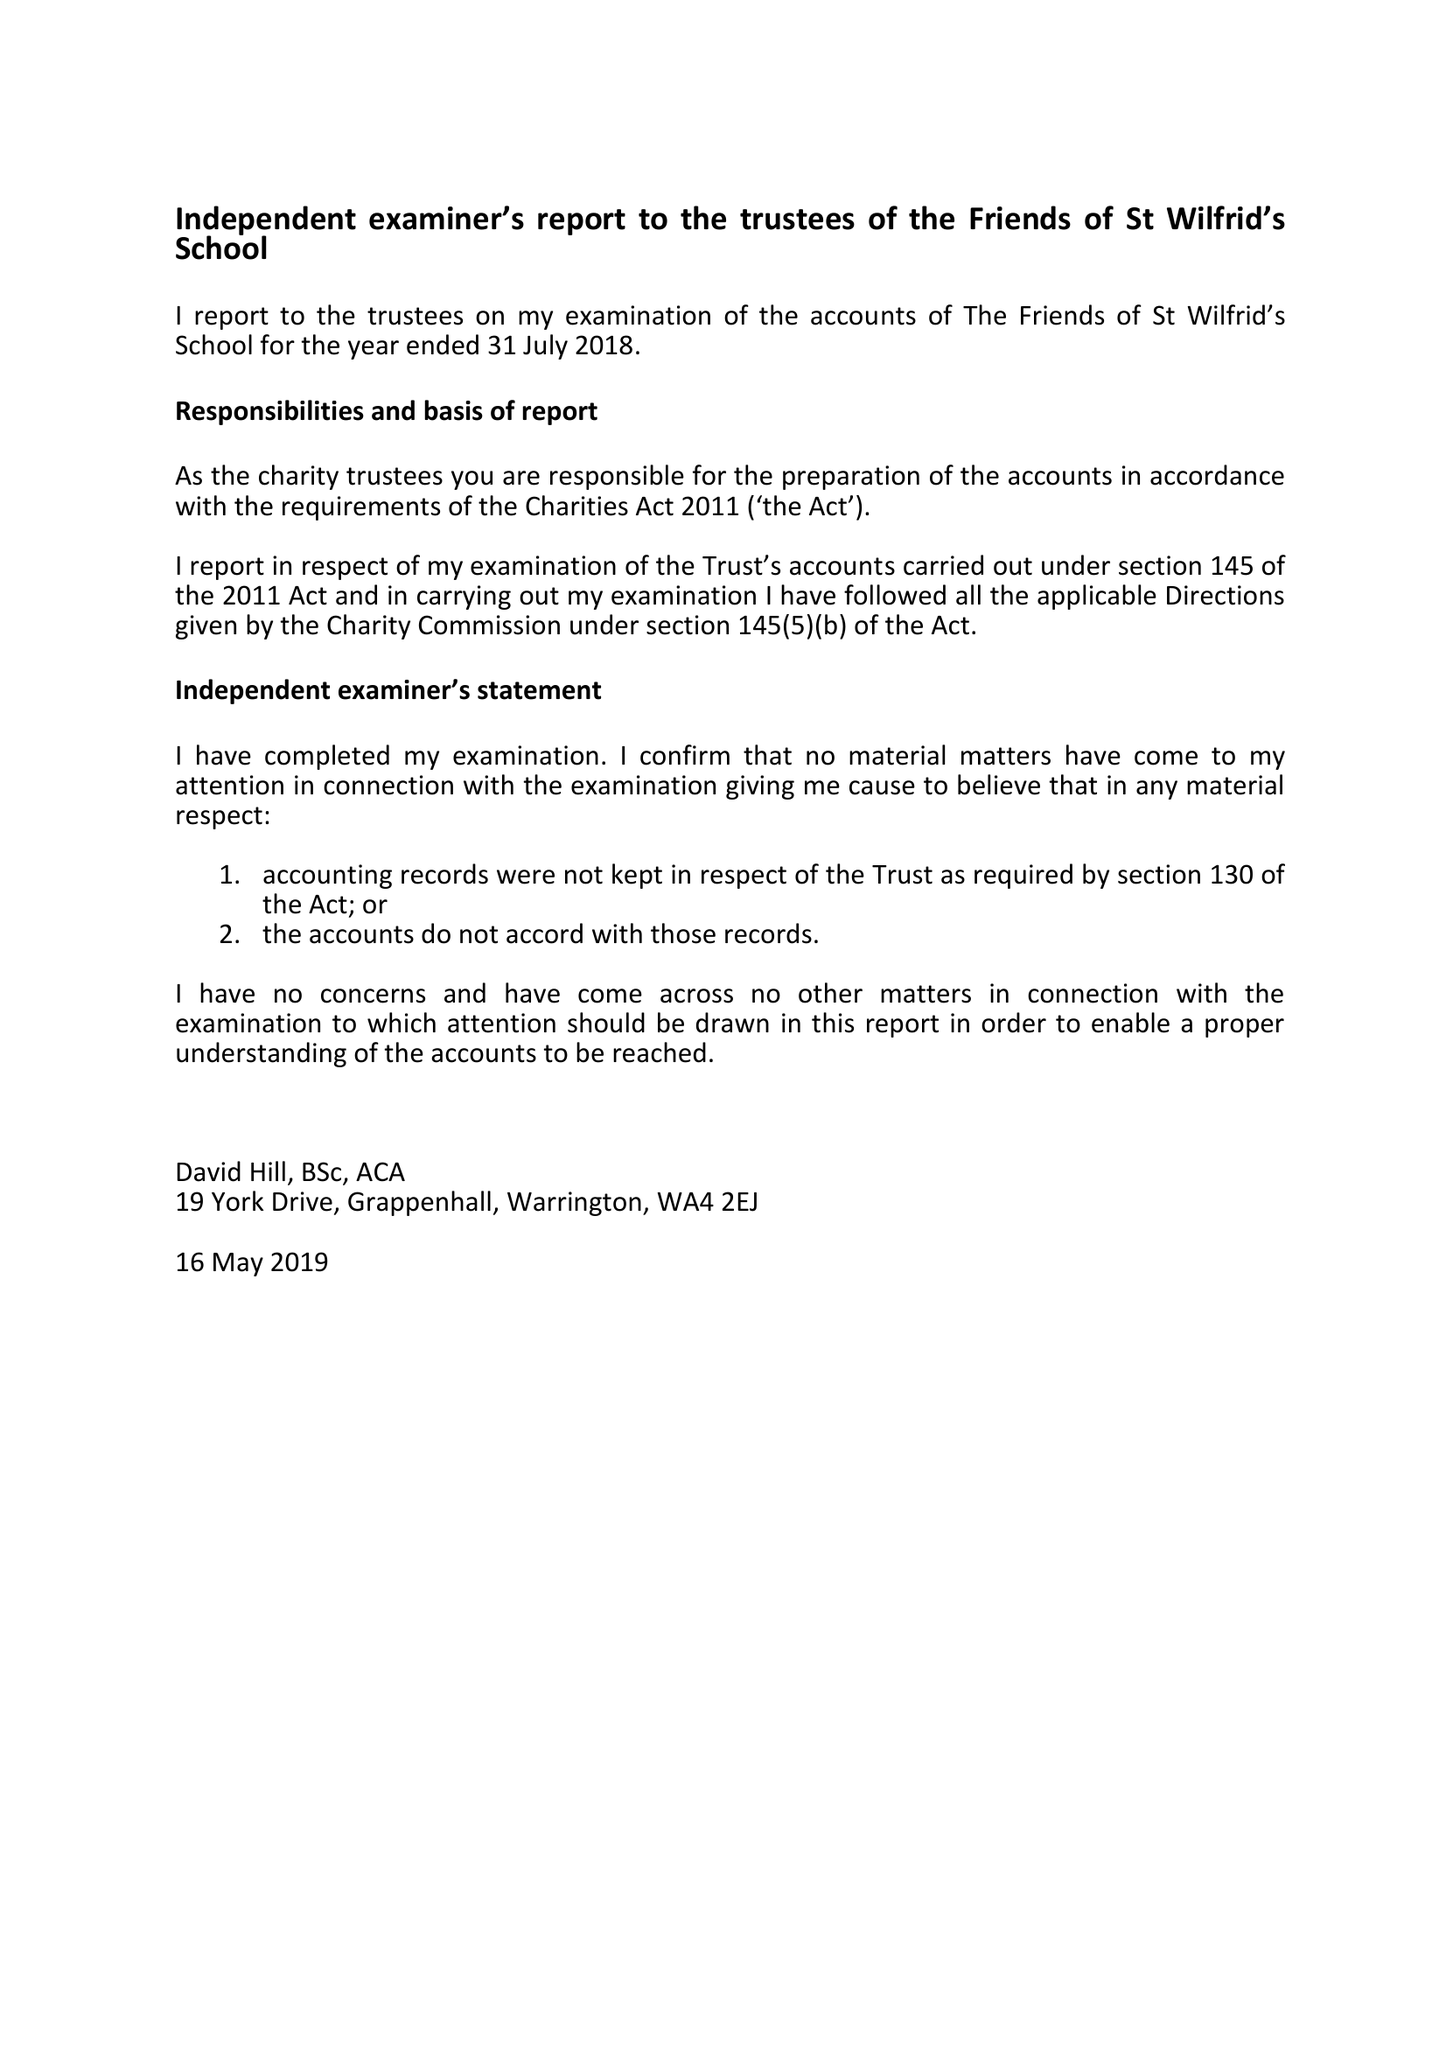What is the value for the income_annually_in_british_pounds?
Answer the question using a single word or phrase. 27370.77 